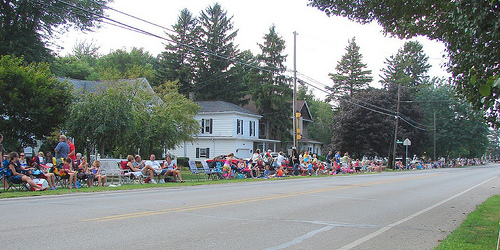<image>
Can you confirm if the house is under the car? No. The house is not positioned under the car. The vertical relationship between these objects is different. 